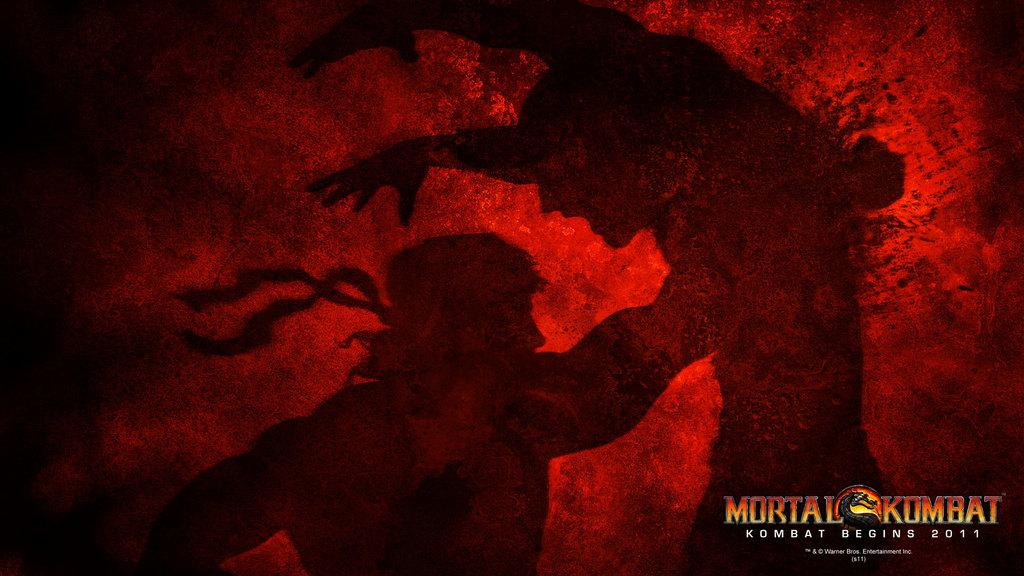Is this promoting a game?
Make the answer very short. Yes. When does combat begin?
Make the answer very short. 2011. 